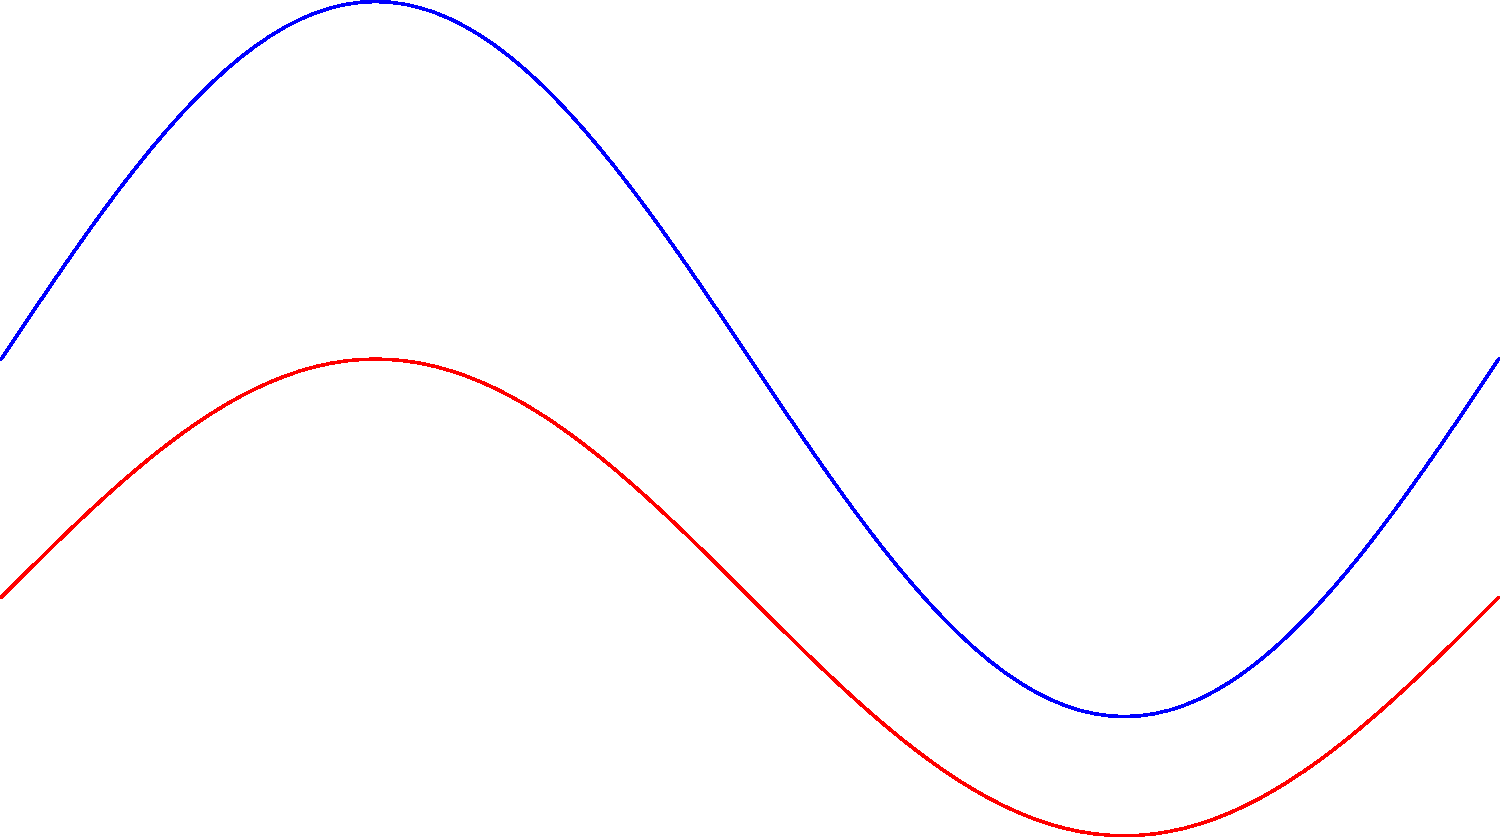As a financial literacy trainer, you're discussing the importance of health and productivity in the workplace. You present a graph showing force-time curves for heel strike and forefoot strike running gaits. Based on the graph, which running gait appears to have higher mechanical efficiency and why might this be relevant to employee wellness programs? To analyze the mechanical efficiency of the running gaits, we need to consider the following steps:

1. Observe the force-time curves:
   - Blue curve represents heel strike
   - Red curve represents forefoot strike

2. Compare the peak forces:
   - Heel strike has a higher peak force
   - Forefoot strike has a lower peak force

3. Analyze the shape of the curves:
   - Heel strike has a sharper, more abrupt peak
   - Forefoot strike has a smoother, more gradual curve

4. Consider the implications:
   - Higher peak forces in heel strike indicate greater impact shock
   - Smoother curve in forefoot strike suggests better force distribution over time

5. Relate to mechanical efficiency:
   - Lower peak forces and smoother force distribution generally indicate higher mechanical efficiency
   - Forefoot strike appears to have higher mechanical efficiency

6. Relevance to employee wellness programs:
   - More efficient running technique may reduce injury risk
   - Lower injury risk can lead to fewer sick days and higher productivity
   - Promoting proper running technique can be part of a comprehensive wellness program
   - Improved employee health can potentially reduce healthcare costs for the company

The forefoot strike gait appears to have higher mechanical efficiency due to its lower peak forces and smoother force distribution over time. This information is relevant to employee wellness programs as it can help reduce injury risk, improve overall health, and potentially lead to cost savings for the company through reduced healthcare expenses and increased productivity.
Answer: Forefoot strike; reduces injury risk and healthcare costs, potentially increasing productivity. 